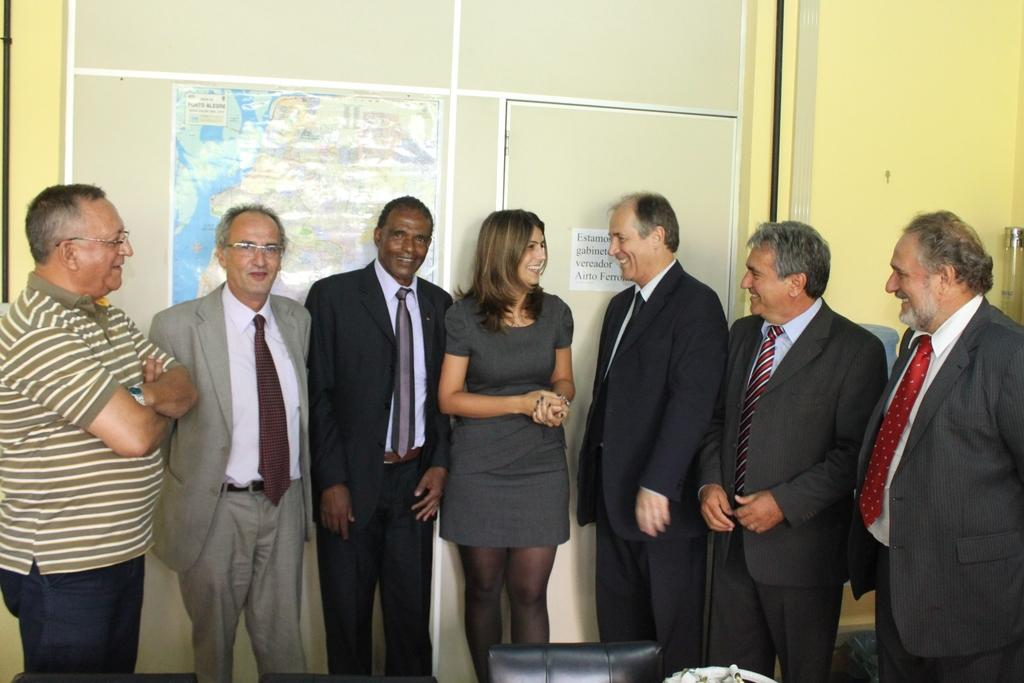What can be seen in the image involving people? There are people standing in the image. What type of furniture is present in the image? There is a chair in the image. What is attached to the chair? A map is attached at the back of the chair. What type of root can be seen growing from the elbow of the person in the image? There is no root or elbow visible in the image; it only shows people standing and a chair with a map attached. 